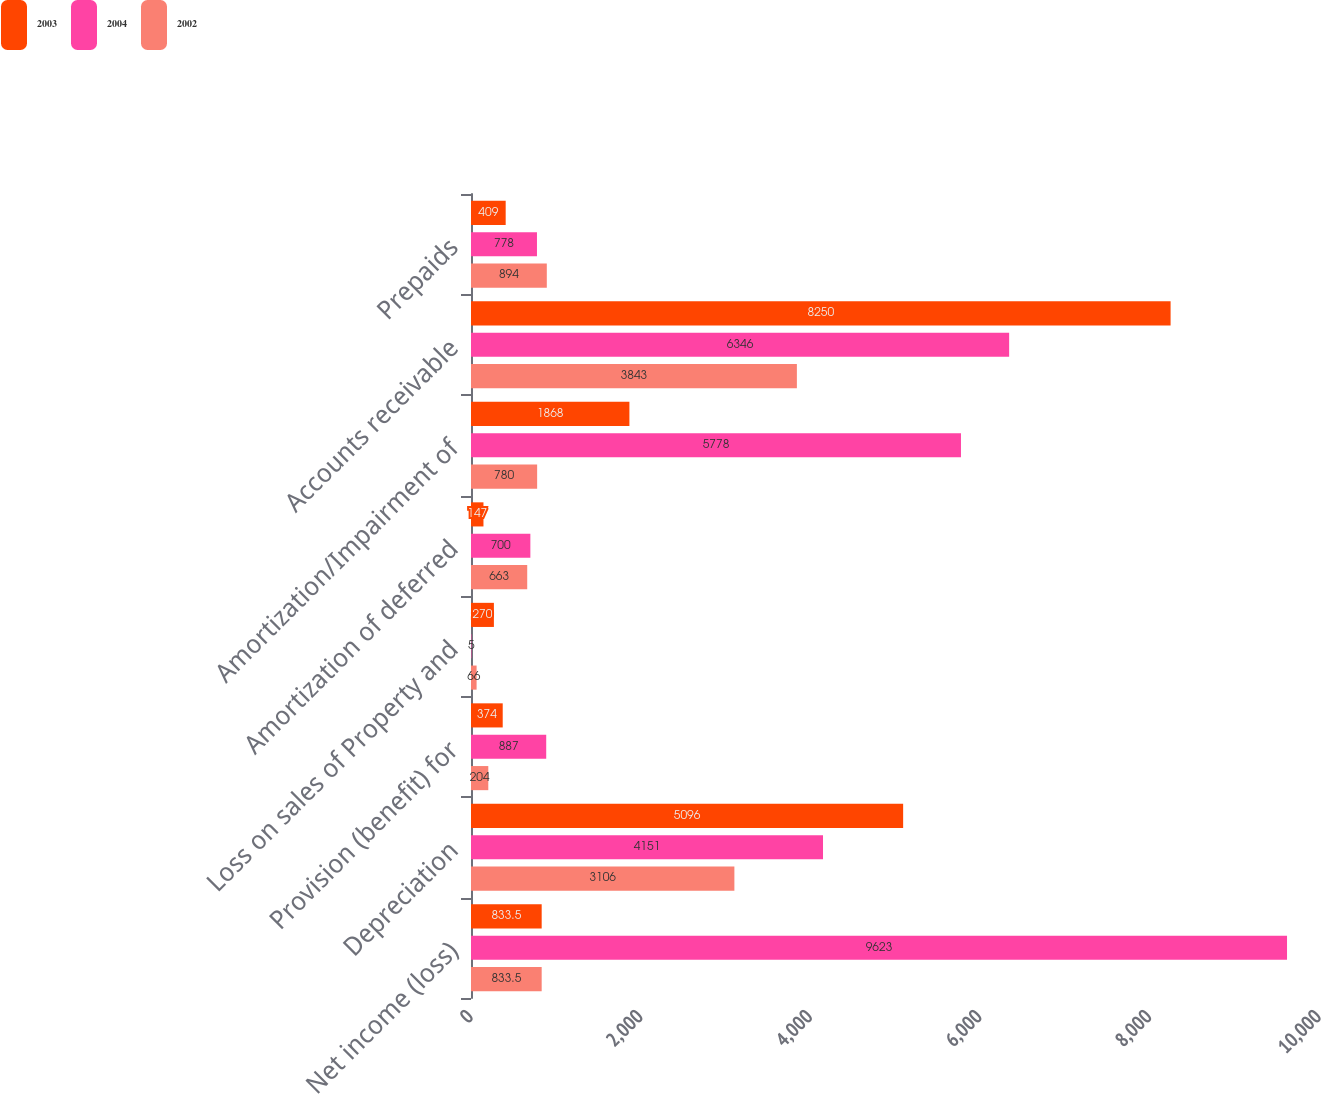Convert chart. <chart><loc_0><loc_0><loc_500><loc_500><stacked_bar_chart><ecel><fcel>Net income (loss)<fcel>Depreciation<fcel>Provision (benefit) for<fcel>Loss on sales of Property and<fcel>Amortization of deferred<fcel>Amortization/Impairment of<fcel>Accounts receivable<fcel>Prepaids<nl><fcel>2003<fcel>833.5<fcel>5096<fcel>374<fcel>270<fcel>147<fcel>1868<fcel>8250<fcel>409<nl><fcel>2004<fcel>9623<fcel>4151<fcel>887<fcel>5<fcel>700<fcel>5778<fcel>6346<fcel>778<nl><fcel>2002<fcel>833.5<fcel>3106<fcel>204<fcel>66<fcel>663<fcel>780<fcel>3843<fcel>894<nl></chart> 